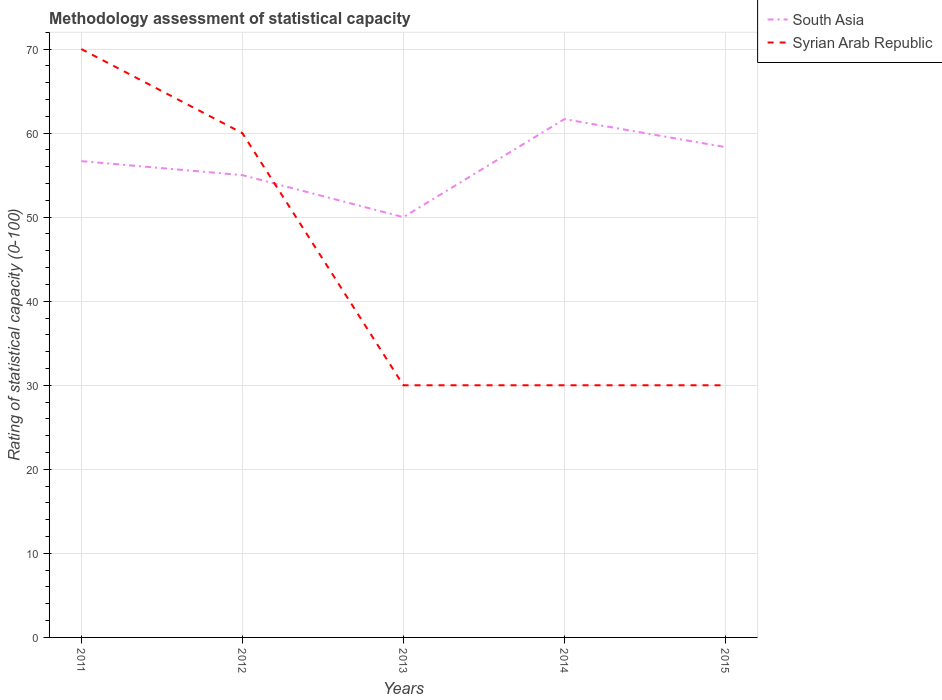Does the line corresponding to South Asia intersect with the line corresponding to Syrian Arab Republic?
Make the answer very short. Yes. Is the number of lines equal to the number of legend labels?
Your answer should be very brief. Yes. Across all years, what is the maximum rating of statistical capacity in South Asia?
Keep it short and to the point. 50. In which year was the rating of statistical capacity in South Asia maximum?
Provide a succinct answer. 2013. What is the total rating of statistical capacity in Syrian Arab Republic in the graph?
Keep it short and to the point. 30. What is the difference between the highest and the second highest rating of statistical capacity in Syrian Arab Republic?
Give a very brief answer. 40. Is the rating of statistical capacity in Syrian Arab Republic strictly greater than the rating of statistical capacity in South Asia over the years?
Provide a succinct answer. No. What is the difference between two consecutive major ticks on the Y-axis?
Keep it short and to the point. 10. Are the values on the major ticks of Y-axis written in scientific E-notation?
Provide a succinct answer. No. Does the graph contain any zero values?
Your answer should be very brief. No. Does the graph contain grids?
Your answer should be very brief. Yes. Where does the legend appear in the graph?
Offer a terse response. Top right. How many legend labels are there?
Provide a short and direct response. 2. What is the title of the graph?
Keep it short and to the point. Methodology assessment of statistical capacity. What is the label or title of the Y-axis?
Your answer should be very brief. Rating of statistical capacity (0-100). What is the Rating of statistical capacity (0-100) of South Asia in 2011?
Your answer should be compact. 56.67. What is the Rating of statistical capacity (0-100) in Syrian Arab Republic in 2011?
Make the answer very short. 70. What is the Rating of statistical capacity (0-100) in South Asia in 2013?
Offer a terse response. 50. What is the Rating of statistical capacity (0-100) of South Asia in 2014?
Offer a terse response. 61.67. What is the Rating of statistical capacity (0-100) of South Asia in 2015?
Offer a very short reply. 58.33. Across all years, what is the maximum Rating of statistical capacity (0-100) in South Asia?
Keep it short and to the point. 61.67. Across all years, what is the minimum Rating of statistical capacity (0-100) in Syrian Arab Republic?
Offer a terse response. 30. What is the total Rating of statistical capacity (0-100) in South Asia in the graph?
Offer a terse response. 281.67. What is the total Rating of statistical capacity (0-100) of Syrian Arab Republic in the graph?
Ensure brevity in your answer.  220. What is the difference between the Rating of statistical capacity (0-100) of Syrian Arab Republic in 2011 and that in 2012?
Make the answer very short. 10. What is the difference between the Rating of statistical capacity (0-100) in South Asia in 2011 and that in 2013?
Your answer should be very brief. 6.67. What is the difference between the Rating of statistical capacity (0-100) of Syrian Arab Republic in 2011 and that in 2013?
Make the answer very short. 40. What is the difference between the Rating of statistical capacity (0-100) of South Asia in 2011 and that in 2014?
Provide a short and direct response. -5. What is the difference between the Rating of statistical capacity (0-100) of Syrian Arab Republic in 2011 and that in 2014?
Give a very brief answer. 40. What is the difference between the Rating of statistical capacity (0-100) of South Asia in 2011 and that in 2015?
Give a very brief answer. -1.67. What is the difference between the Rating of statistical capacity (0-100) in South Asia in 2012 and that in 2013?
Provide a short and direct response. 5. What is the difference between the Rating of statistical capacity (0-100) in South Asia in 2012 and that in 2014?
Provide a short and direct response. -6.67. What is the difference between the Rating of statistical capacity (0-100) of South Asia in 2012 and that in 2015?
Your response must be concise. -3.33. What is the difference between the Rating of statistical capacity (0-100) in Syrian Arab Republic in 2012 and that in 2015?
Your answer should be compact. 30. What is the difference between the Rating of statistical capacity (0-100) of South Asia in 2013 and that in 2014?
Give a very brief answer. -11.67. What is the difference between the Rating of statistical capacity (0-100) in South Asia in 2013 and that in 2015?
Your answer should be very brief. -8.33. What is the difference between the Rating of statistical capacity (0-100) of Syrian Arab Republic in 2014 and that in 2015?
Provide a succinct answer. 0. What is the difference between the Rating of statistical capacity (0-100) of South Asia in 2011 and the Rating of statistical capacity (0-100) of Syrian Arab Republic in 2012?
Provide a succinct answer. -3.33. What is the difference between the Rating of statistical capacity (0-100) in South Asia in 2011 and the Rating of statistical capacity (0-100) in Syrian Arab Republic in 2013?
Give a very brief answer. 26.67. What is the difference between the Rating of statistical capacity (0-100) in South Asia in 2011 and the Rating of statistical capacity (0-100) in Syrian Arab Republic in 2014?
Ensure brevity in your answer.  26.67. What is the difference between the Rating of statistical capacity (0-100) in South Asia in 2011 and the Rating of statistical capacity (0-100) in Syrian Arab Republic in 2015?
Your answer should be very brief. 26.67. What is the difference between the Rating of statistical capacity (0-100) in South Asia in 2012 and the Rating of statistical capacity (0-100) in Syrian Arab Republic in 2013?
Provide a short and direct response. 25. What is the difference between the Rating of statistical capacity (0-100) in South Asia in 2012 and the Rating of statistical capacity (0-100) in Syrian Arab Republic in 2015?
Provide a short and direct response. 25. What is the difference between the Rating of statistical capacity (0-100) of South Asia in 2013 and the Rating of statistical capacity (0-100) of Syrian Arab Republic in 2014?
Provide a short and direct response. 20. What is the difference between the Rating of statistical capacity (0-100) of South Asia in 2013 and the Rating of statistical capacity (0-100) of Syrian Arab Republic in 2015?
Provide a succinct answer. 20. What is the difference between the Rating of statistical capacity (0-100) of South Asia in 2014 and the Rating of statistical capacity (0-100) of Syrian Arab Republic in 2015?
Provide a short and direct response. 31.67. What is the average Rating of statistical capacity (0-100) in South Asia per year?
Your answer should be compact. 56.33. In the year 2011, what is the difference between the Rating of statistical capacity (0-100) of South Asia and Rating of statistical capacity (0-100) of Syrian Arab Republic?
Make the answer very short. -13.33. In the year 2012, what is the difference between the Rating of statistical capacity (0-100) of South Asia and Rating of statistical capacity (0-100) of Syrian Arab Republic?
Offer a terse response. -5. In the year 2013, what is the difference between the Rating of statistical capacity (0-100) in South Asia and Rating of statistical capacity (0-100) in Syrian Arab Republic?
Keep it short and to the point. 20. In the year 2014, what is the difference between the Rating of statistical capacity (0-100) of South Asia and Rating of statistical capacity (0-100) of Syrian Arab Republic?
Your response must be concise. 31.67. In the year 2015, what is the difference between the Rating of statistical capacity (0-100) of South Asia and Rating of statistical capacity (0-100) of Syrian Arab Republic?
Ensure brevity in your answer.  28.33. What is the ratio of the Rating of statistical capacity (0-100) of South Asia in 2011 to that in 2012?
Make the answer very short. 1.03. What is the ratio of the Rating of statistical capacity (0-100) of South Asia in 2011 to that in 2013?
Provide a succinct answer. 1.13. What is the ratio of the Rating of statistical capacity (0-100) of Syrian Arab Republic in 2011 to that in 2013?
Make the answer very short. 2.33. What is the ratio of the Rating of statistical capacity (0-100) of South Asia in 2011 to that in 2014?
Ensure brevity in your answer.  0.92. What is the ratio of the Rating of statistical capacity (0-100) of Syrian Arab Republic in 2011 to that in 2014?
Your answer should be compact. 2.33. What is the ratio of the Rating of statistical capacity (0-100) in South Asia in 2011 to that in 2015?
Give a very brief answer. 0.97. What is the ratio of the Rating of statistical capacity (0-100) of Syrian Arab Republic in 2011 to that in 2015?
Make the answer very short. 2.33. What is the ratio of the Rating of statistical capacity (0-100) in Syrian Arab Republic in 2012 to that in 2013?
Offer a terse response. 2. What is the ratio of the Rating of statistical capacity (0-100) in South Asia in 2012 to that in 2014?
Your answer should be compact. 0.89. What is the ratio of the Rating of statistical capacity (0-100) in South Asia in 2012 to that in 2015?
Make the answer very short. 0.94. What is the ratio of the Rating of statistical capacity (0-100) in Syrian Arab Republic in 2012 to that in 2015?
Your answer should be compact. 2. What is the ratio of the Rating of statistical capacity (0-100) of South Asia in 2013 to that in 2014?
Give a very brief answer. 0.81. What is the ratio of the Rating of statistical capacity (0-100) of Syrian Arab Republic in 2013 to that in 2015?
Your answer should be very brief. 1. What is the ratio of the Rating of statistical capacity (0-100) of South Asia in 2014 to that in 2015?
Offer a very short reply. 1.06. What is the difference between the highest and the lowest Rating of statistical capacity (0-100) in South Asia?
Provide a succinct answer. 11.67. What is the difference between the highest and the lowest Rating of statistical capacity (0-100) of Syrian Arab Republic?
Your response must be concise. 40. 